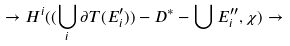<formula> <loc_0><loc_0><loc_500><loc_500>\rightarrow H ^ { i } ( ( \bigcup _ { i } \partial T ( E _ { i } ^ { \prime } ) ) - D ^ { * } - \bigcup E _ { i } ^ { \prime \prime } , \chi ) \rightarrow</formula> 